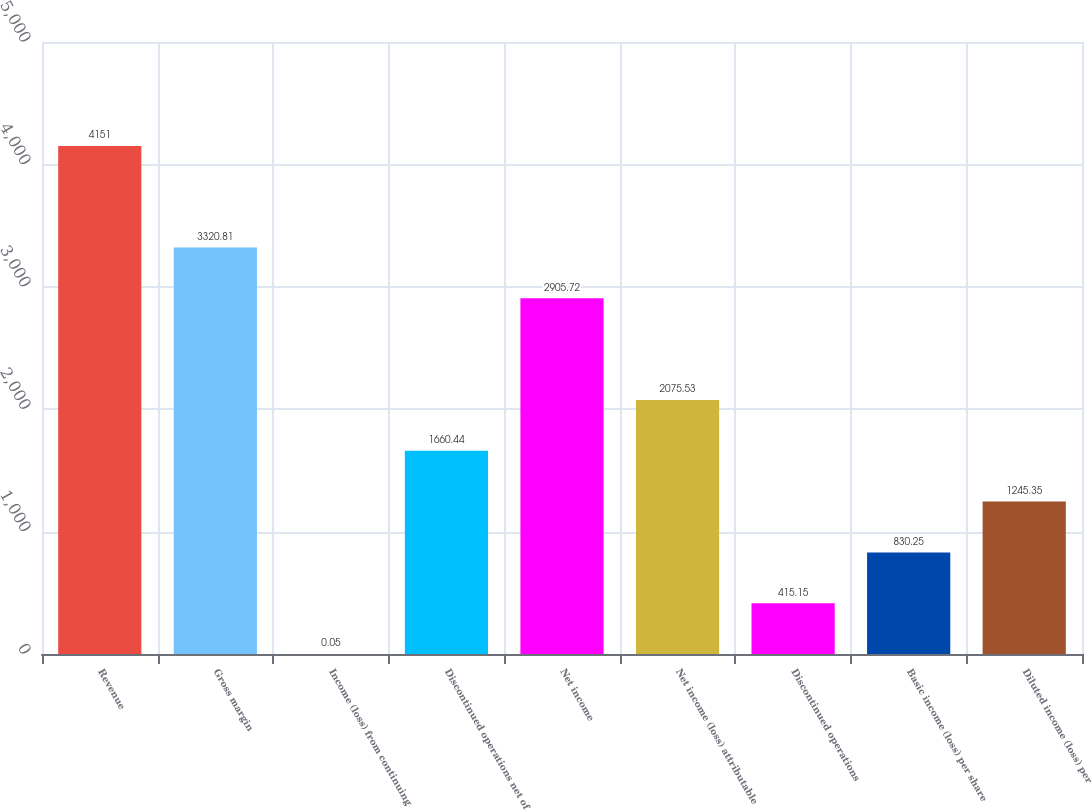<chart> <loc_0><loc_0><loc_500><loc_500><bar_chart><fcel>Revenue<fcel>Gross margin<fcel>Income (loss) from continuing<fcel>Discontinued operations net of<fcel>Net income<fcel>Net income (loss) attributable<fcel>Discontinued operations<fcel>Basic income (loss) per share<fcel>Diluted income (loss) per<nl><fcel>4151<fcel>3320.81<fcel>0.05<fcel>1660.44<fcel>2905.72<fcel>2075.53<fcel>415.15<fcel>830.25<fcel>1245.35<nl></chart> 